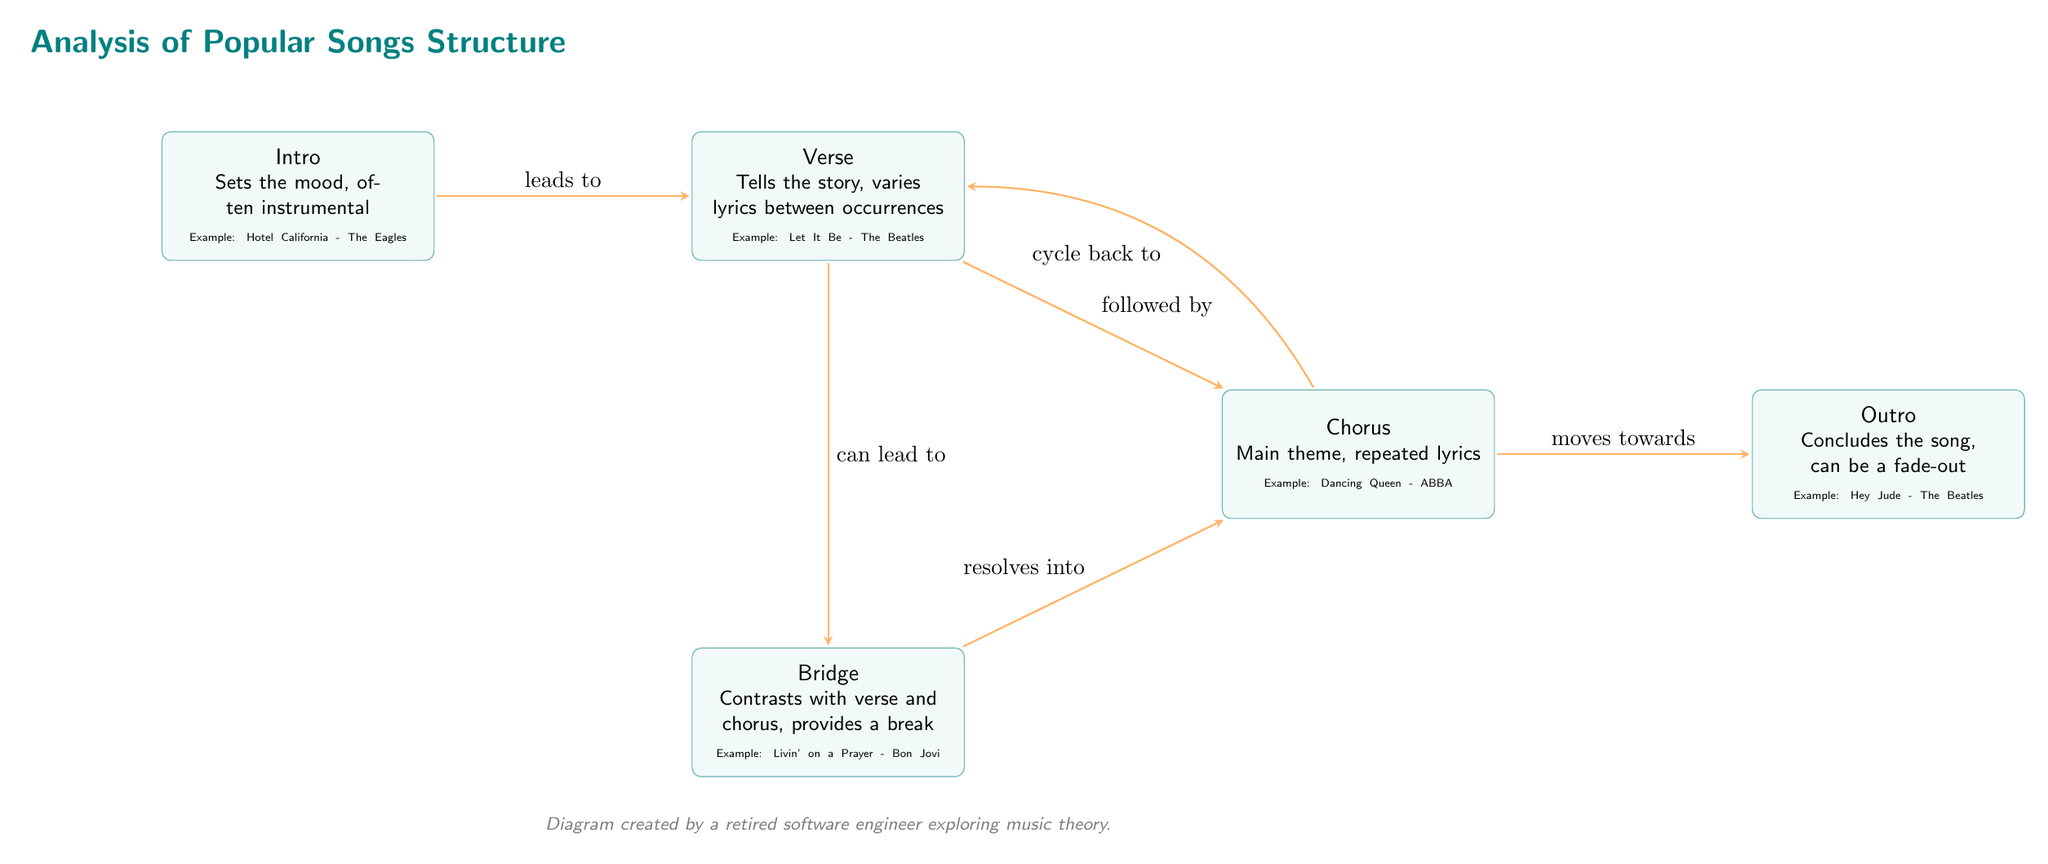What is the first section of a song according to the diagram? The diagram indicates that the first section of a song is the "Intro," which sets the mood and is often instrumental.
Answer: Intro Which section follows the verse? The diagram shows an arrow indicating that the "Chorus" follows the "Verse," connected by the "followed by" label.
Answer: Chorus How many main sections are represented in the diagram? The diagram features five distinct sections: Intro, Verse, Chorus, Bridge, and Outro, summing up to a total count of five.
Answer: 5 What is the purpose of the bridge in a song structure? The diagram states that the "Bridge" contrasts with the verse and chorus, providing a break in the song structure.
Answer: Provides a break From which section does the outro flow? According to the diagram's flow, the "Outro" moves towards the end of the song from the "Chorus," indicating a transition.
Answer: Chorus Which section can lead to the bridge according to the diagram? The diagram indicates that the "Verse" can lead to the "Bridge," showcasing a directional connection between these sections.
Answer: Verse What is a characteristic of the chorus? The diagram notes that the "Chorus" contains the main theme and has repeated lyrics, defining its structure and function in a song.
Answer: Main theme, repeated lyrics What does the intro lead to? The visual flow of the diagram demonstrates that the "Intro" leads directly to the "Verse," implying a sequential progression.
Answer: Verse What is an example of a song given in the outro section? The diagram specifically cites "Hey Jude" by The Beatles as an example in the "Outro" section.
Answer: Hey Jude - The Beatles 